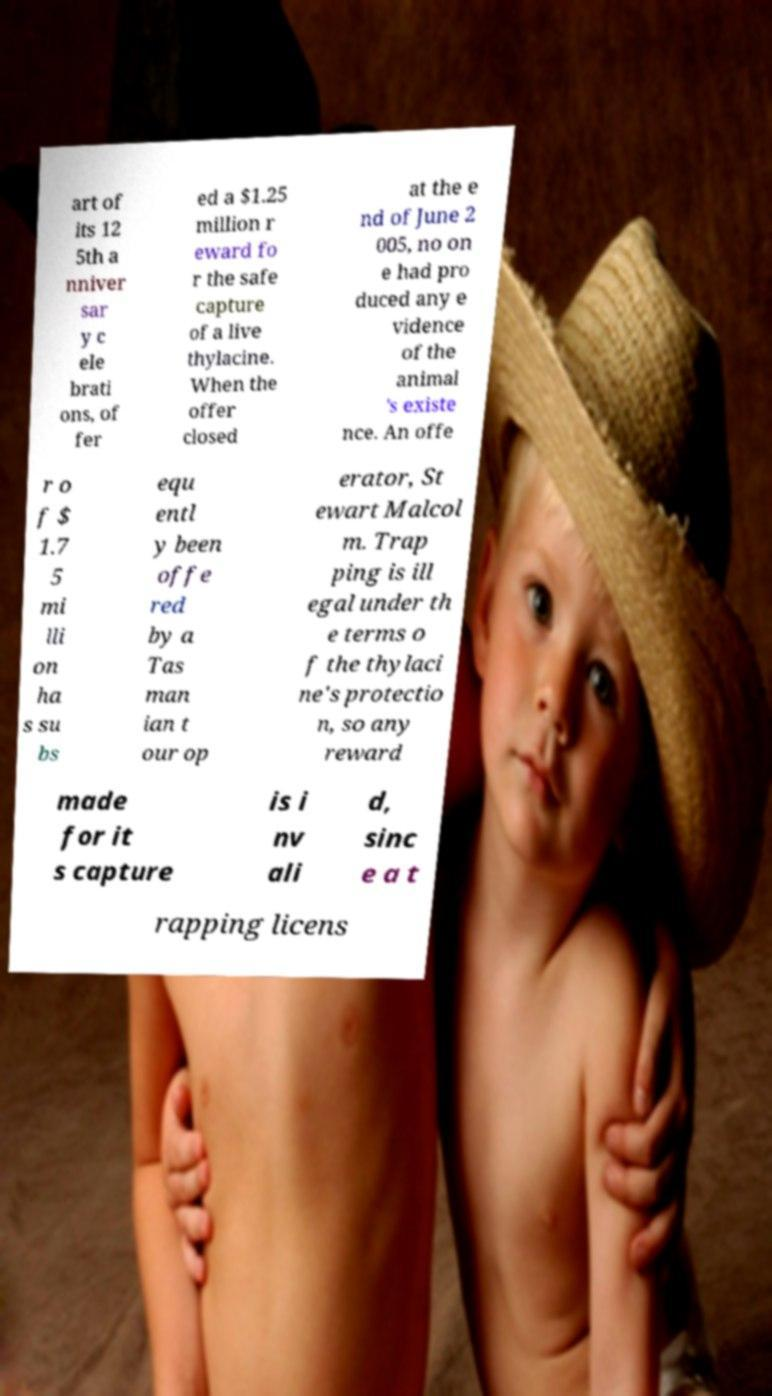Can you accurately transcribe the text from the provided image for me? art of its 12 5th a nniver sar y c ele brati ons, of fer ed a $1.25 million r eward fo r the safe capture of a live thylacine. When the offer closed at the e nd of June 2 005, no on e had pro duced any e vidence of the animal 's existe nce. An offe r o f $ 1.7 5 mi lli on ha s su bs equ entl y been offe red by a Tas man ian t our op erator, St ewart Malcol m. Trap ping is ill egal under th e terms o f the thylaci ne's protectio n, so any reward made for it s capture is i nv ali d, sinc e a t rapping licens 